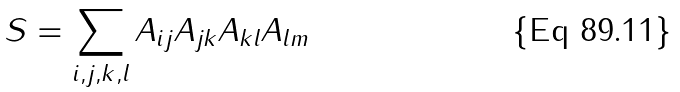Convert formula to latex. <formula><loc_0><loc_0><loc_500><loc_500>S = \sum _ { i , j , k , l } A _ { i j } A _ { j k } A _ { k l } A _ { l m }</formula> 